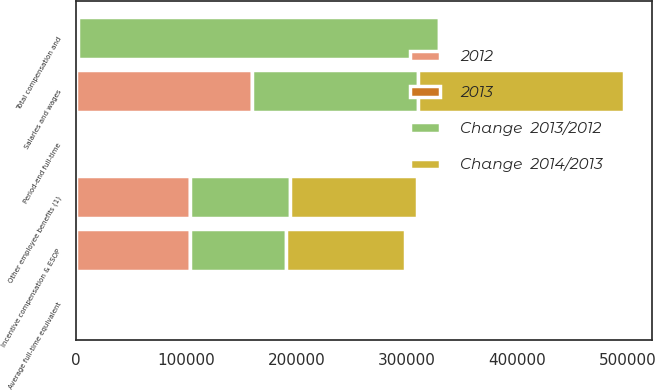<chart> <loc_0><loc_0><loc_500><loc_500><stacked_bar_chart><ecel><fcel>Salaries and wages<fcel>Incentive compensation & ESOP<fcel>Other employee benefits (1)<fcel>Total compensation and<fcel>Period-end full-time<fcel>Average full-time equivalent<nl><fcel>Change  2014/2013<fcel>186763<fcel>107564<fcel>115159<fcel>1864.5<fcel>1914<fcel>1815<nl><fcel>2012<fcel>159455<fcel>103494<fcel>103852<fcel>1864.5<fcel>1704<fcel>1669<nl><fcel>2013<fcel>17.1<fcel>3.9<fcel>10.9<fcel>11.6<fcel>12.3<fcel>8.7<nl><fcel>Change  2013/2012<fcel>150536<fcel>86684<fcel>89722<fcel>326942<fcel>1615<fcel>1581<nl></chart> 